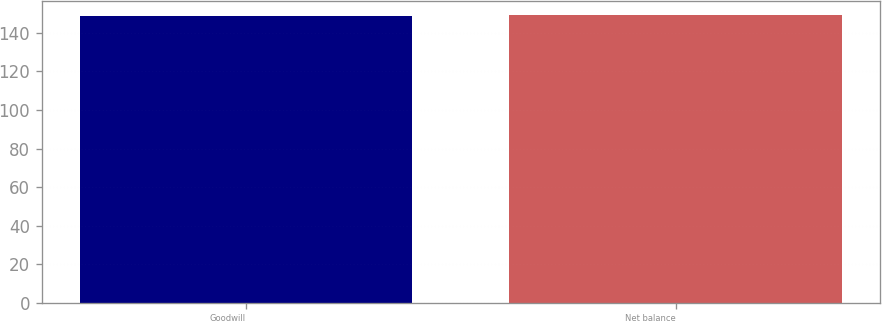<chart> <loc_0><loc_0><loc_500><loc_500><bar_chart><fcel>Goodwill<fcel>Net balance<nl><fcel>149<fcel>149.1<nl></chart> 